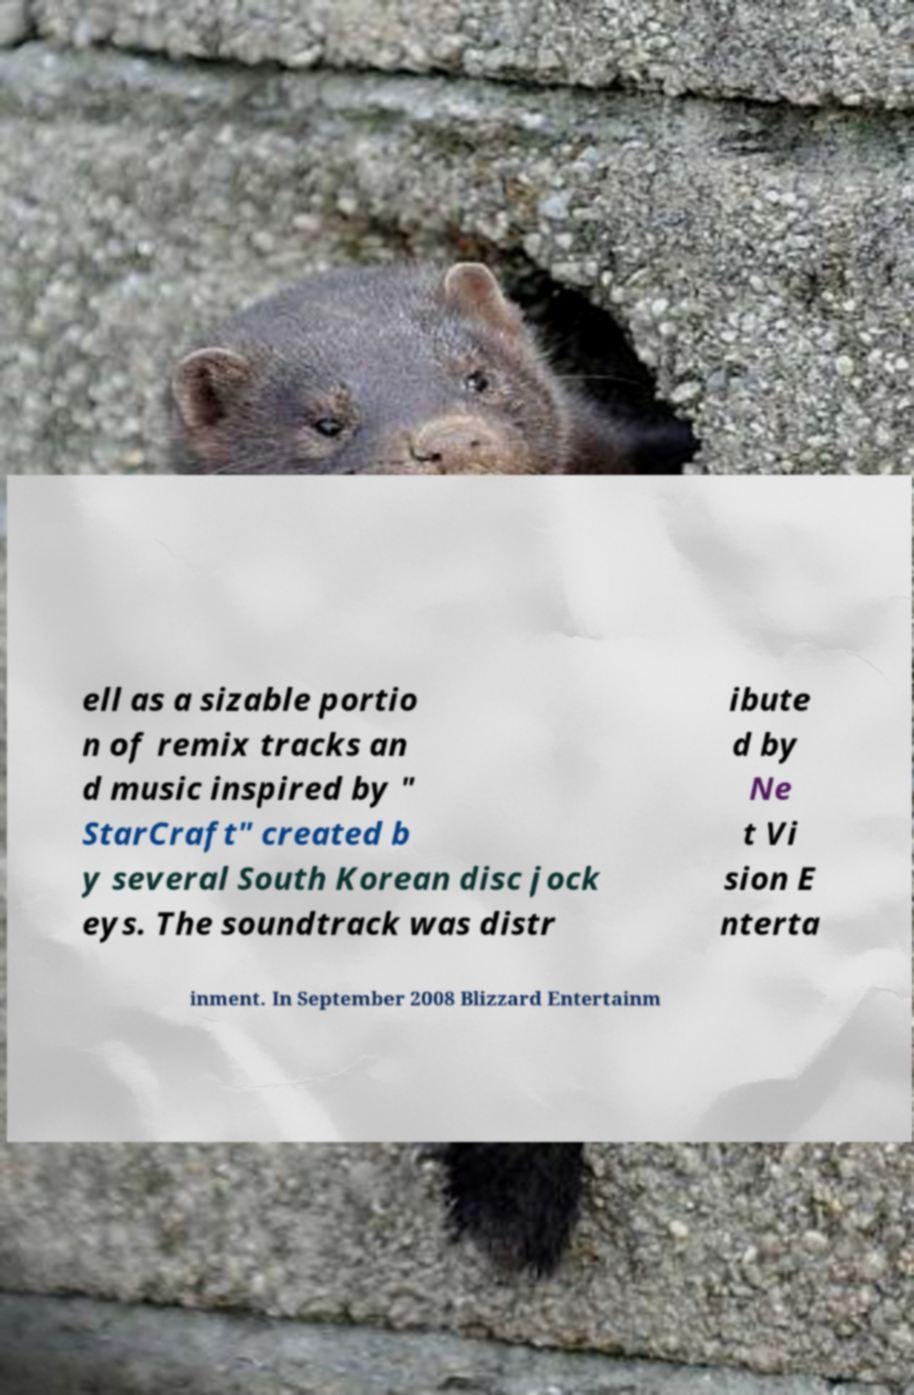Can you read and provide the text displayed in the image?This photo seems to have some interesting text. Can you extract and type it out for me? ell as a sizable portio n of remix tracks an d music inspired by " StarCraft" created b y several South Korean disc jock eys. The soundtrack was distr ibute d by Ne t Vi sion E nterta inment. In September 2008 Blizzard Entertainm 